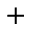<formula> <loc_0><loc_0><loc_500><loc_500>^ { + }</formula> 